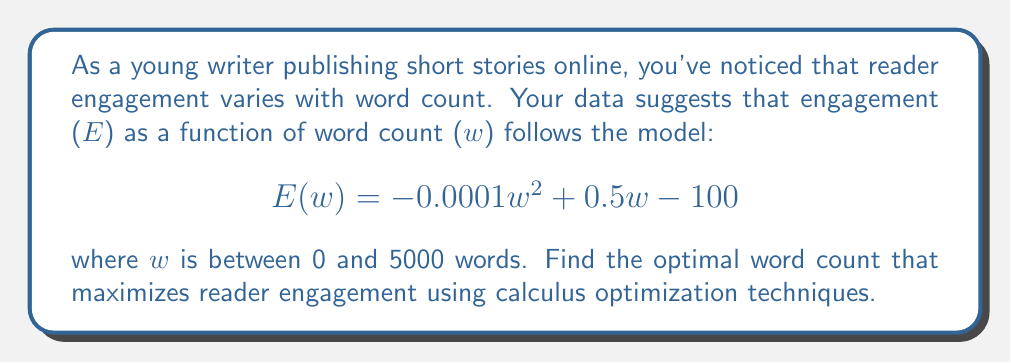Help me with this question. 1. To find the maximum engagement, we need to find the word count where the derivative of $E(w)$ is zero.

2. Calculate the derivative of $E(w)$:
   $$E'(w) = -0.0002w + 0.5$$

3. Set $E'(w) = 0$ and solve for $w$:
   $$-0.0002w + 0.5 = 0$$
   $$-0.0002w = -0.5$$
   $$w = \frac{-0.5}{-0.0002} = 2500$$

4. Verify this is a maximum by checking the second derivative:
   $$E''(w) = -0.0002$$
   Since $E''(w)$ is negative, the critical point is a maximum.

5. Check the endpoint at $w = 5000$ to ensure it's not higher:
   $$E(5000) = -0.0001(5000)^2 + 0.5(5000) - 100 = -750$$
   This is less than $E(2500) = 525$, so 2500 is indeed the global maximum.

6. The optimal word count is 2500 words.
Answer: 2500 words 